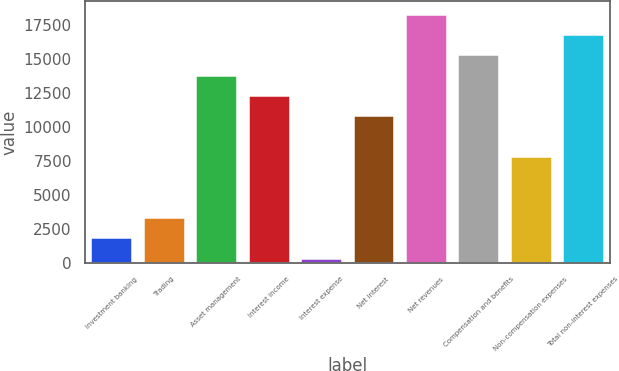Convert chart. <chart><loc_0><loc_0><loc_500><loc_500><bar_chart><fcel>Investment banking<fcel>Trading<fcel>Asset management<fcel>Interest income<fcel>Interest expense<fcel>Net interest<fcel>Net revenues<fcel>Compensation and benefits<fcel>Non-compensation expenses<fcel>Total non-interest expenses<nl><fcel>1858.1<fcel>3357.2<fcel>13850.9<fcel>12351.8<fcel>359<fcel>10852.7<fcel>18348.2<fcel>15350<fcel>7854.5<fcel>16849.1<nl></chart> 